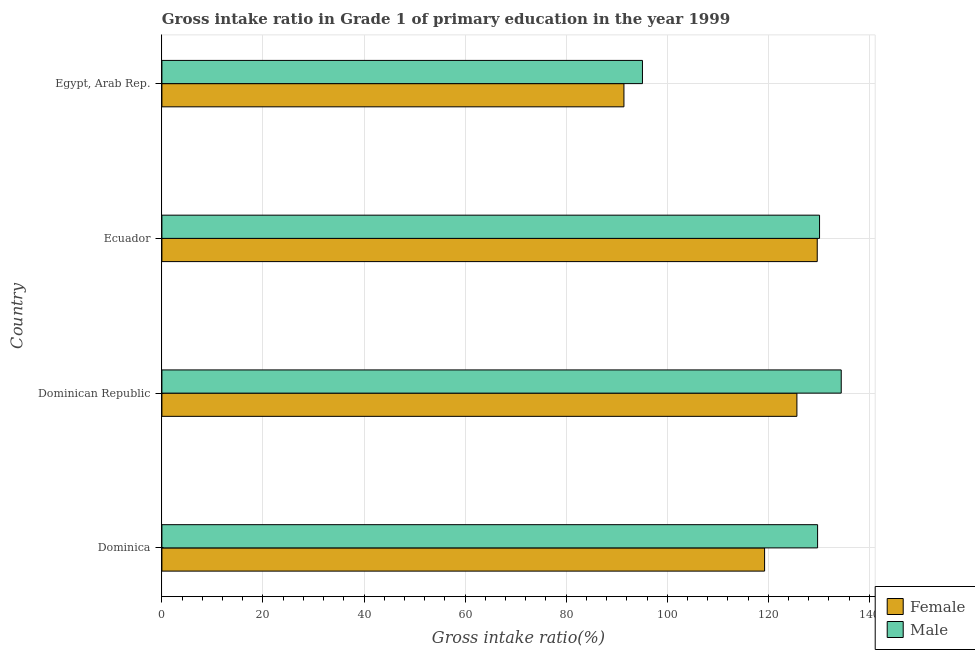How many different coloured bars are there?
Your answer should be very brief. 2. Are the number of bars per tick equal to the number of legend labels?
Provide a short and direct response. Yes. Are the number of bars on each tick of the Y-axis equal?
Offer a terse response. Yes. How many bars are there on the 3rd tick from the bottom?
Ensure brevity in your answer.  2. What is the label of the 2nd group of bars from the top?
Provide a succinct answer. Ecuador. In how many cases, is the number of bars for a given country not equal to the number of legend labels?
Give a very brief answer. 0. What is the gross intake ratio(female) in Egypt, Arab Rep.?
Provide a succinct answer. 91.43. Across all countries, what is the maximum gross intake ratio(male)?
Your answer should be very brief. 134.42. Across all countries, what is the minimum gross intake ratio(male)?
Provide a short and direct response. 95.09. In which country was the gross intake ratio(female) maximum?
Offer a very short reply. Ecuador. In which country was the gross intake ratio(female) minimum?
Your response must be concise. Egypt, Arab Rep. What is the total gross intake ratio(male) in the graph?
Provide a succinct answer. 489.4. What is the difference between the gross intake ratio(female) in Dominica and that in Dominican Republic?
Your response must be concise. -6.4. What is the difference between the gross intake ratio(female) in Ecuador and the gross intake ratio(male) in Dominican Republic?
Keep it short and to the point. -4.75. What is the average gross intake ratio(male) per country?
Offer a terse response. 122.35. What is the difference between the gross intake ratio(male) and gross intake ratio(female) in Dominican Republic?
Your answer should be very brief. 8.77. In how many countries, is the gross intake ratio(male) greater than 32 %?
Give a very brief answer. 4. What is the ratio of the gross intake ratio(male) in Dominica to that in Egypt, Arab Rep.?
Provide a succinct answer. 1.36. Is the difference between the gross intake ratio(female) in Dominica and Dominican Republic greater than the difference between the gross intake ratio(male) in Dominica and Dominican Republic?
Offer a very short reply. No. What is the difference between the highest and the second highest gross intake ratio(female)?
Provide a succinct answer. 4.02. What is the difference between the highest and the lowest gross intake ratio(female)?
Ensure brevity in your answer.  38.25. What does the 2nd bar from the top in Dominica represents?
Your answer should be compact. Female. What does the 2nd bar from the bottom in Dominican Republic represents?
Keep it short and to the point. Male. Are all the bars in the graph horizontal?
Your answer should be compact. Yes. How many countries are there in the graph?
Offer a very short reply. 4. Are the values on the major ticks of X-axis written in scientific E-notation?
Provide a succinct answer. No. Where does the legend appear in the graph?
Provide a short and direct response. Bottom right. How are the legend labels stacked?
Keep it short and to the point. Vertical. What is the title of the graph?
Offer a very short reply. Gross intake ratio in Grade 1 of primary education in the year 1999. Does "Under-five" appear as one of the legend labels in the graph?
Your response must be concise. No. What is the label or title of the X-axis?
Give a very brief answer. Gross intake ratio(%). What is the label or title of the Y-axis?
Your response must be concise. Country. What is the Gross intake ratio(%) in Female in Dominica?
Offer a very short reply. 119.26. What is the Gross intake ratio(%) in Male in Dominica?
Keep it short and to the point. 129.75. What is the Gross intake ratio(%) in Female in Dominican Republic?
Offer a very short reply. 125.65. What is the Gross intake ratio(%) in Male in Dominican Republic?
Ensure brevity in your answer.  134.42. What is the Gross intake ratio(%) in Female in Ecuador?
Keep it short and to the point. 129.68. What is the Gross intake ratio(%) in Male in Ecuador?
Provide a succinct answer. 130.13. What is the Gross intake ratio(%) of Female in Egypt, Arab Rep.?
Ensure brevity in your answer.  91.43. What is the Gross intake ratio(%) in Male in Egypt, Arab Rep.?
Keep it short and to the point. 95.09. Across all countries, what is the maximum Gross intake ratio(%) of Female?
Your answer should be compact. 129.68. Across all countries, what is the maximum Gross intake ratio(%) in Male?
Provide a succinct answer. 134.42. Across all countries, what is the minimum Gross intake ratio(%) of Female?
Make the answer very short. 91.43. Across all countries, what is the minimum Gross intake ratio(%) of Male?
Keep it short and to the point. 95.09. What is the total Gross intake ratio(%) in Female in the graph?
Provide a succinct answer. 466.01. What is the total Gross intake ratio(%) in Male in the graph?
Provide a succinct answer. 489.4. What is the difference between the Gross intake ratio(%) in Female in Dominica and that in Dominican Republic?
Your answer should be very brief. -6.4. What is the difference between the Gross intake ratio(%) in Male in Dominica and that in Dominican Republic?
Your answer should be compact. -4.68. What is the difference between the Gross intake ratio(%) in Female in Dominica and that in Ecuador?
Give a very brief answer. -10.42. What is the difference between the Gross intake ratio(%) of Male in Dominica and that in Ecuador?
Offer a terse response. -0.38. What is the difference between the Gross intake ratio(%) of Female in Dominica and that in Egypt, Arab Rep.?
Make the answer very short. 27.83. What is the difference between the Gross intake ratio(%) of Male in Dominica and that in Egypt, Arab Rep.?
Your answer should be very brief. 34.66. What is the difference between the Gross intake ratio(%) in Female in Dominican Republic and that in Ecuador?
Make the answer very short. -4.02. What is the difference between the Gross intake ratio(%) of Male in Dominican Republic and that in Ecuador?
Your answer should be compact. 4.29. What is the difference between the Gross intake ratio(%) of Female in Dominican Republic and that in Egypt, Arab Rep.?
Provide a succinct answer. 34.23. What is the difference between the Gross intake ratio(%) of Male in Dominican Republic and that in Egypt, Arab Rep.?
Provide a succinct answer. 39.33. What is the difference between the Gross intake ratio(%) of Female in Ecuador and that in Egypt, Arab Rep.?
Keep it short and to the point. 38.25. What is the difference between the Gross intake ratio(%) in Male in Ecuador and that in Egypt, Arab Rep.?
Your response must be concise. 35.04. What is the difference between the Gross intake ratio(%) in Female in Dominica and the Gross intake ratio(%) in Male in Dominican Republic?
Make the answer very short. -15.17. What is the difference between the Gross intake ratio(%) in Female in Dominica and the Gross intake ratio(%) in Male in Ecuador?
Your answer should be compact. -10.87. What is the difference between the Gross intake ratio(%) in Female in Dominica and the Gross intake ratio(%) in Male in Egypt, Arab Rep.?
Your response must be concise. 24.17. What is the difference between the Gross intake ratio(%) in Female in Dominican Republic and the Gross intake ratio(%) in Male in Ecuador?
Your answer should be compact. -4.48. What is the difference between the Gross intake ratio(%) of Female in Dominican Republic and the Gross intake ratio(%) of Male in Egypt, Arab Rep.?
Offer a terse response. 30.56. What is the difference between the Gross intake ratio(%) of Female in Ecuador and the Gross intake ratio(%) of Male in Egypt, Arab Rep.?
Ensure brevity in your answer.  34.58. What is the average Gross intake ratio(%) in Female per country?
Your response must be concise. 116.5. What is the average Gross intake ratio(%) of Male per country?
Provide a short and direct response. 122.35. What is the difference between the Gross intake ratio(%) of Female and Gross intake ratio(%) of Male in Dominica?
Your answer should be very brief. -10.49. What is the difference between the Gross intake ratio(%) in Female and Gross intake ratio(%) in Male in Dominican Republic?
Your answer should be very brief. -8.77. What is the difference between the Gross intake ratio(%) of Female and Gross intake ratio(%) of Male in Ecuador?
Offer a terse response. -0.46. What is the difference between the Gross intake ratio(%) of Female and Gross intake ratio(%) of Male in Egypt, Arab Rep.?
Provide a short and direct response. -3.67. What is the ratio of the Gross intake ratio(%) in Female in Dominica to that in Dominican Republic?
Provide a succinct answer. 0.95. What is the ratio of the Gross intake ratio(%) of Male in Dominica to that in Dominican Republic?
Your answer should be compact. 0.97. What is the ratio of the Gross intake ratio(%) in Female in Dominica to that in Ecuador?
Offer a very short reply. 0.92. What is the ratio of the Gross intake ratio(%) of Male in Dominica to that in Ecuador?
Keep it short and to the point. 1. What is the ratio of the Gross intake ratio(%) in Female in Dominica to that in Egypt, Arab Rep.?
Offer a terse response. 1.3. What is the ratio of the Gross intake ratio(%) of Male in Dominica to that in Egypt, Arab Rep.?
Provide a short and direct response. 1.36. What is the ratio of the Gross intake ratio(%) of Female in Dominican Republic to that in Ecuador?
Your response must be concise. 0.97. What is the ratio of the Gross intake ratio(%) in Male in Dominican Republic to that in Ecuador?
Provide a short and direct response. 1.03. What is the ratio of the Gross intake ratio(%) of Female in Dominican Republic to that in Egypt, Arab Rep.?
Offer a very short reply. 1.37. What is the ratio of the Gross intake ratio(%) in Male in Dominican Republic to that in Egypt, Arab Rep.?
Your answer should be compact. 1.41. What is the ratio of the Gross intake ratio(%) of Female in Ecuador to that in Egypt, Arab Rep.?
Give a very brief answer. 1.42. What is the ratio of the Gross intake ratio(%) in Male in Ecuador to that in Egypt, Arab Rep.?
Offer a terse response. 1.37. What is the difference between the highest and the second highest Gross intake ratio(%) in Female?
Offer a very short reply. 4.02. What is the difference between the highest and the second highest Gross intake ratio(%) in Male?
Your answer should be very brief. 4.29. What is the difference between the highest and the lowest Gross intake ratio(%) in Female?
Ensure brevity in your answer.  38.25. What is the difference between the highest and the lowest Gross intake ratio(%) of Male?
Keep it short and to the point. 39.33. 